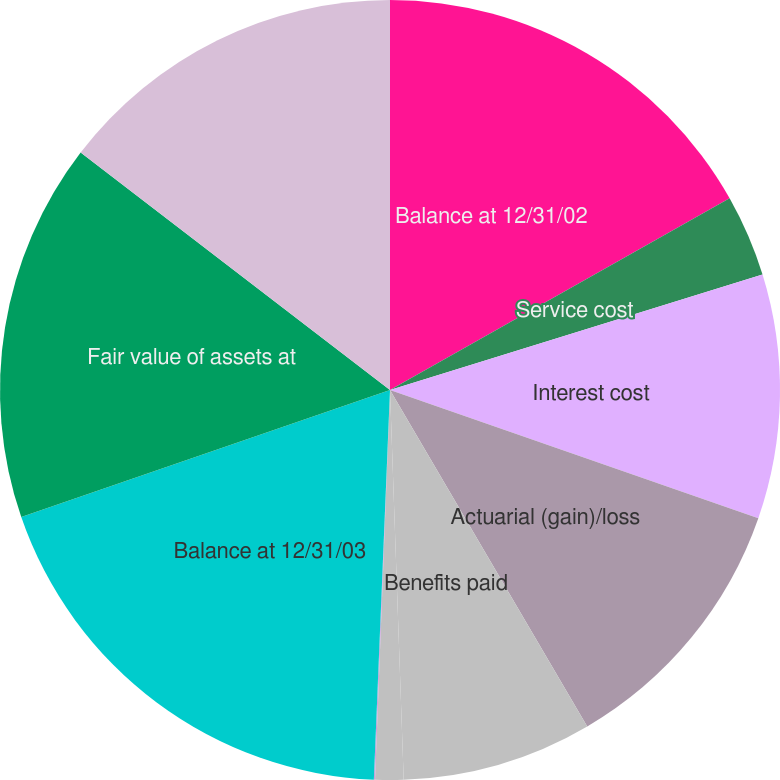Convert chart to OTSL. <chart><loc_0><loc_0><loc_500><loc_500><pie_chart><fcel>Balance at 12/31/02<fcel>Service cost<fcel>Interest cost<fcel>Actuarial (gain)/loss<fcel>Benefits paid<fcel>Curtailment loss<fcel>Special termination benefits<fcel>Balance at 12/31/03<fcel>Fair value of assets at<fcel>Actual return on plan assets<nl><fcel>16.82%<fcel>3.4%<fcel>10.11%<fcel>11.23%<fcel>7.88%<fcel>1.17%<fcel>0.05%<fcel>19.06%<fcel>15.7%<fcel>14.58%<nl></chart> 